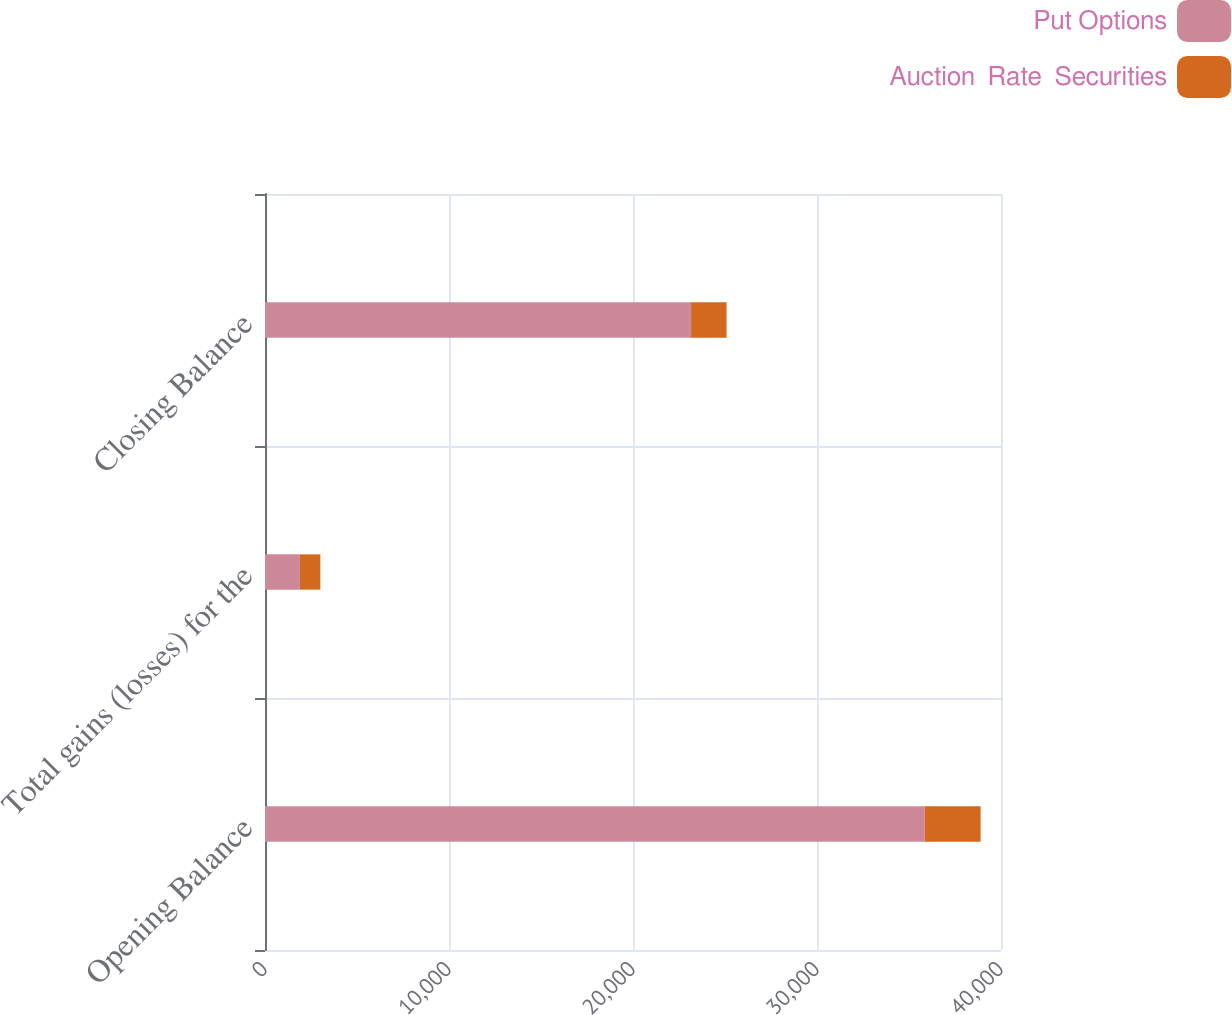Convert chart. <chart><loc_0><loc_0><loc_500><loc_500><stacked_bar_chart><ecel><fcel>Opening Balance<fcel>Total gains (losses) for the<fcel>Closing Balance<nl><fcel>Put Options<fcel>35852<fcel>1897<fcel>23156<nl><fcel>Auction  Rate  Securities<fcel>3041<fcel>1112<fcel>1929<nl></chart> 